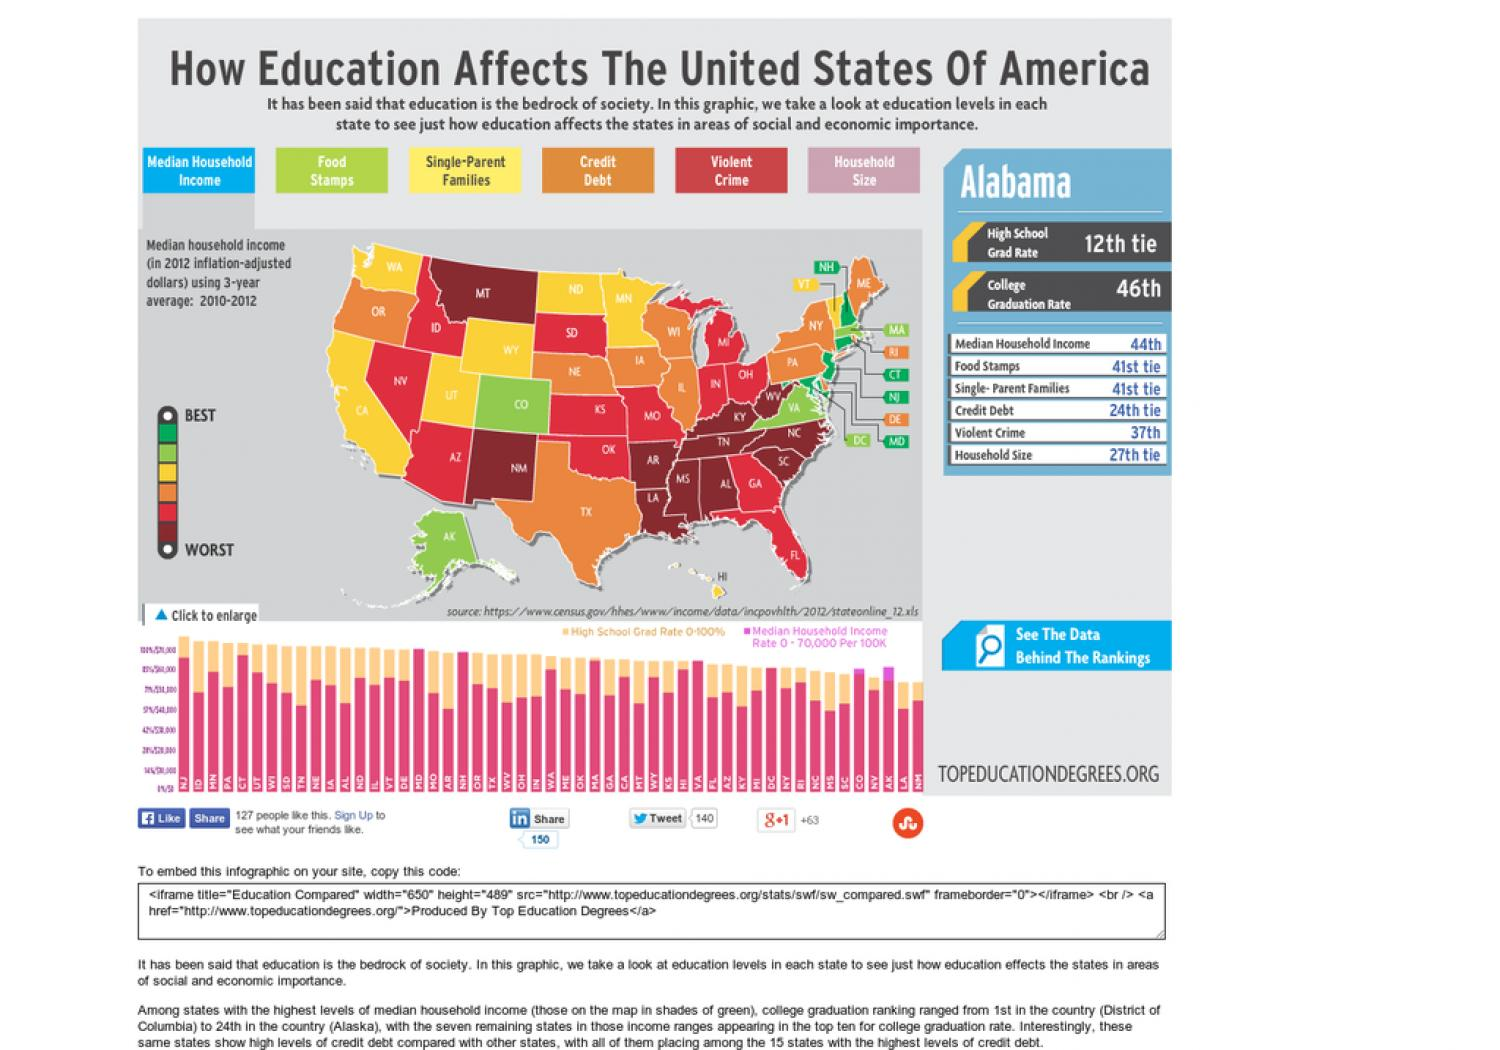List a handful of essential elements in this visual. According to the color code provided, the median household income for the state of New Jersey falls within the range designated for high income households. Eight states are shown in yellow. 